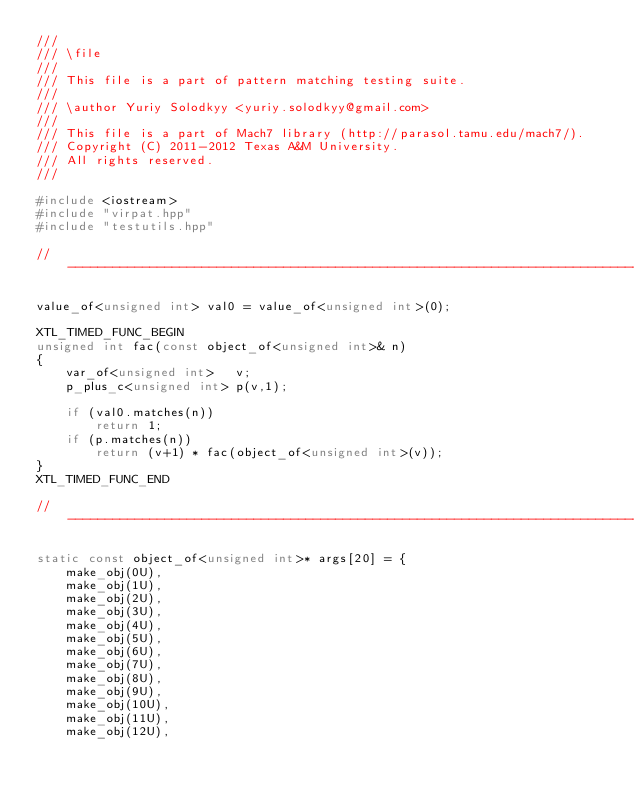<code> <loc_0><loc_0><loc_500><loc_500><_C++_>///
/// \file
///
/// This file is a part of pattern matching testing suite.
///
/// \author Yuriy Solodkyy <yuriy.solodkyy@gmail.com>
///
/// This file is a part of Mach7 library (http://parasol.tamu.edu/mach7/).
/// Copyright (C) 2011-2012 Texas A&M University.
/// All rights reserved.
///

#include <iostream>
#include "virpat.hpp"
#include "testutils.hpp"

//------------------------------------------------------------------------------

value_of<unsigned int> val0 = value_of<unsigned int>(0);

XTL_TIMED_FUNC_BEGIN
unsigned int fac(const object_of<unsigned int>& n)
{
    var_of<unsigned int>   v;
    p_plus_c<unsigned int> p(v,1);

    if (val0.matches(n))
        return 1;
    if (p.matches(n))
        return (v+1) * fac(object_of<unsigned int>(v));
}
XTL_TIMED_FUNC_END

//------------------------------------------------------------------------------

static const object_of<unsigned int>* args[20] = {
    make_obj(0U),
    make_obj(1U),
    make_obj(2U),
    make_obj(3U),
    make_obj(4U),
    make_obj(5U),
    make_obj(6U),
    make_obj(7U),
    make_obj(8U),
    make_obj(9U),
    make_obj(10U),
    make_obj(11U),
    make_obj(12U),</code> 